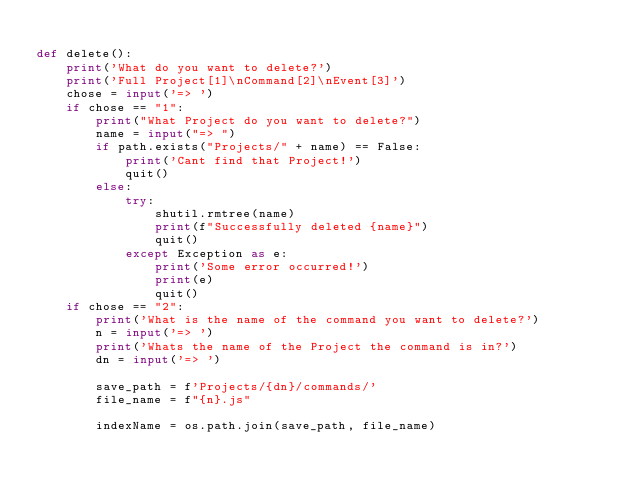<code> <loc_0><loc_0><loc_500><loc_500><_Python_>
def delete():
    print('What do you want to delete?')
    print('Full Project[1]\nCommand[2]\nEvent[3]')
    chose = input('=> ')
    if chose == "1":
        print("What Project do you want to delete?")
        name = input("=> ")
        if path.exists("Projects/" + name) == False:
            print('Cant find that Project!')
            quit()
        else:
            try:
                shutil.rmtree(name)
                print(f"Successfully deleted {name}")
                quit()
            except Exception as e:
                print('Some error occurred!')
                print(e)
                quit()
    if chose == "2":
        print('What is the name of the command you want to delete?')
        n = input('=> ')
        print('Whats the name of the Project the command is in?')
        dn = input('=> ')

        save_path = f'Projects/{dn}/commands/'
        file_name = f"{n}.js"

        indexName = os.path.join(save_path, file_name)</code> 